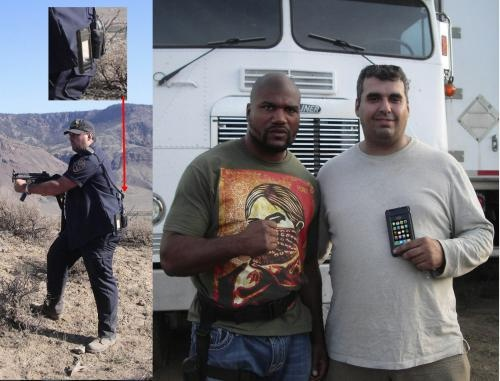Describe the objects in this image and their specific colors. I can see truck in lightblue, lightgray, gray, black, and darkgray tones, people in lightblue, darkgray, gray, black, and lightgray tones, people in lightblue, black, gray, maroon, and brown tones, people in lightblue, black, gray, and darkgray tones, and people in lightblue, black, and gray tones in this image. 